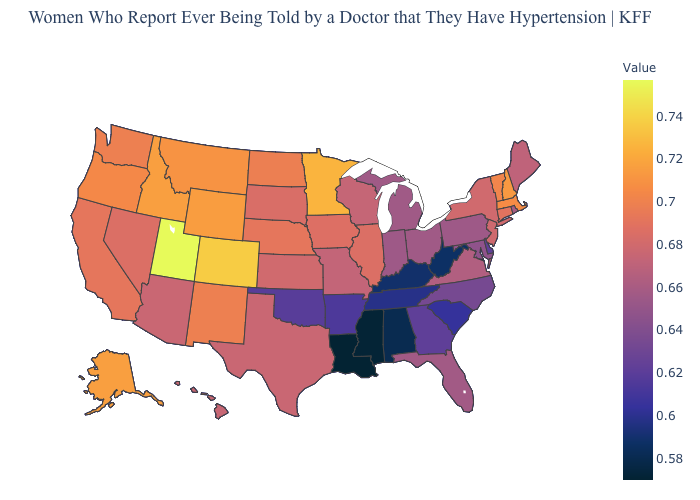Does Idaho have the highest value in the West?
Keep it brief. No. Which states hav the highest value in the MidWest?
Answer briefly. Minnesota. Which states have the lowest value in the USA?
Short answer required. Louisiana. Among the states that border Idaho , does Utah have the highest value?
Give a very brief answer. Yes. Among the states that border Florida , does Alabama have the lowest value?
Answer briefly. Yes. Which states have the lowest value in the USA?
Be succinct. Louisiana. Among the states that border Kentucky , does Ohio have the lowest value?
Short answer required. No. 